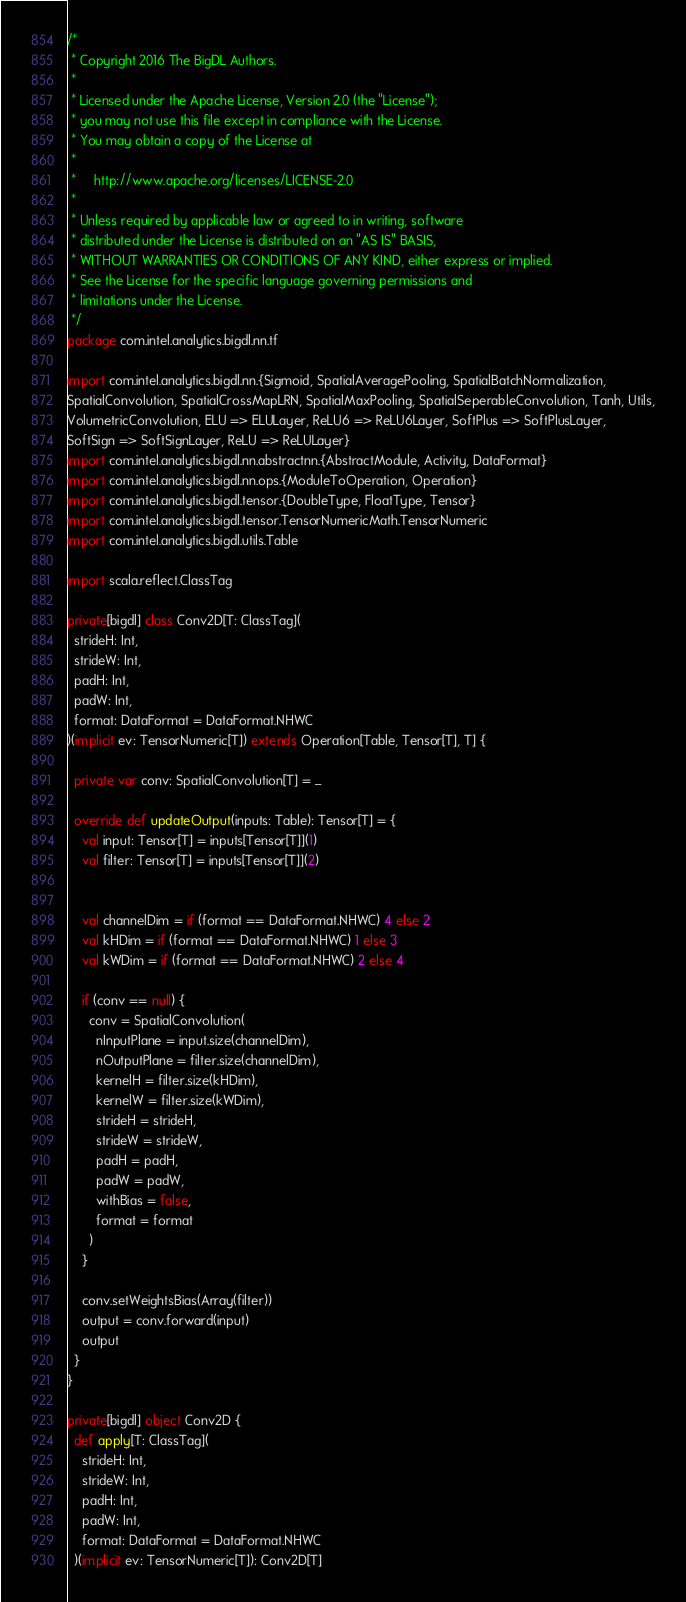Convert code to text. <code><loc_0><loc_0><loc_500><loc_500><_Scala_>/*
 * Copyright 2016 The BigDL Authors.
 *
 * Licensed under the Apache License, Version 2.0 (the "License");
 * you may not use this file except in compliance with the License.
 * You may obtain a copy of the License at
 *
 *     http://www.apache.org/licenses/LICENSE-2.0
 *
 * Unless required by applicable law or agreed to in writing, software
 * distributed under the License is distributed on an "AS IS" BASIS,
 * WITHOUT WARRANTIES OR CONDITIONS OF ANY KIND, either express or implied.
 * See the License for the specific language governing permissions and
 * limitations under the License.
 */
package com.intel.analytics.bigdl.nn.tf

import com.intel.analytics.bigdl.nn.{Sigmoid, SpatialAveragePooling, SpatialBatchNormalization,
SpatialConvolution, SpatialCrossMapLRN, SpatialMaxPooling, SpatialSeperableConvolution, Tanh, Utils,
VolumetricConvolution, ELU => ELULayer, ReLU6 => ReLU6Layer, SoftPlus => SoftPlusLayer,
SoftSign => SoftSignLayer, ReLU => ReLULayer}
import com.intel.analytics.bigdl.nn.abstractnn.{AbstractModule, Activity, DataFormat}
import com.intel.analytics.bigdl.nn.ops.{ModuleToOperation, Operation}
import com.intel.analytics.bigdl.tensor.{DoubleType, FloatType, Tensor}
import com.intel.analytics.bigdl.tensor.TensorNumericMath.TensorNumeric
import com.intel.analytics.bigdl.utils.Table

import scala.reflect.ClassTag

private[bigdl] class Conv2D[T: ClassTag](
  strideH: Int,
  strideW: Int,
  padH: Int,
  padW: Int,
  format: DataFormat = DataFormat.NHWC
)(implicit ev: TensorNumeric[T]) extends Operation[Table, Tensor[T], T] {

  private var conv: SpatialConvolution[T] = _

  override def updateOutput(inputs: Table): Tensor[T] = {
    val input: Tensor[T] = inputs[Tensor[T]](1)
    val filter: Tensor[T] = inputs[Tensor[T]](2)


    val channelDim = if (format == DataFormat.NHWC) 4 else 2
    val kHDim = if (format == DataFormat.NHWC) 1 else 3
    val kWDim = if (format == DataFormat.NHWC) 2 else 4

    if (conv == null) {
      conv = SpatialConvolution(
        nInputPlane = input.size(channelDim),
        nOutputPlane = filter.size(channelDim),
        kernelH = filter.size(kHDim),
        kernelW = filter.size(kWDim),
        strideH = strideH,
        strideW = strideW,
        padH = padH,
        padW = padW,
        withBias = false,
        format = format
      )
    }

    conv.setWeightsBias(Array(filter))
    output = conv.forward(input)
    output
  }
}

private[bigdl] object Conv2D {
  def apply[T: ClassTag](
    strideH: Int,
    strideW: Int,
    padH: Int,
    padW: Int,
    format: DataFormat = DataFormat.NHWC
  )(implicit ev: TensorNumeric[T]): Conv2D[T]</code> 